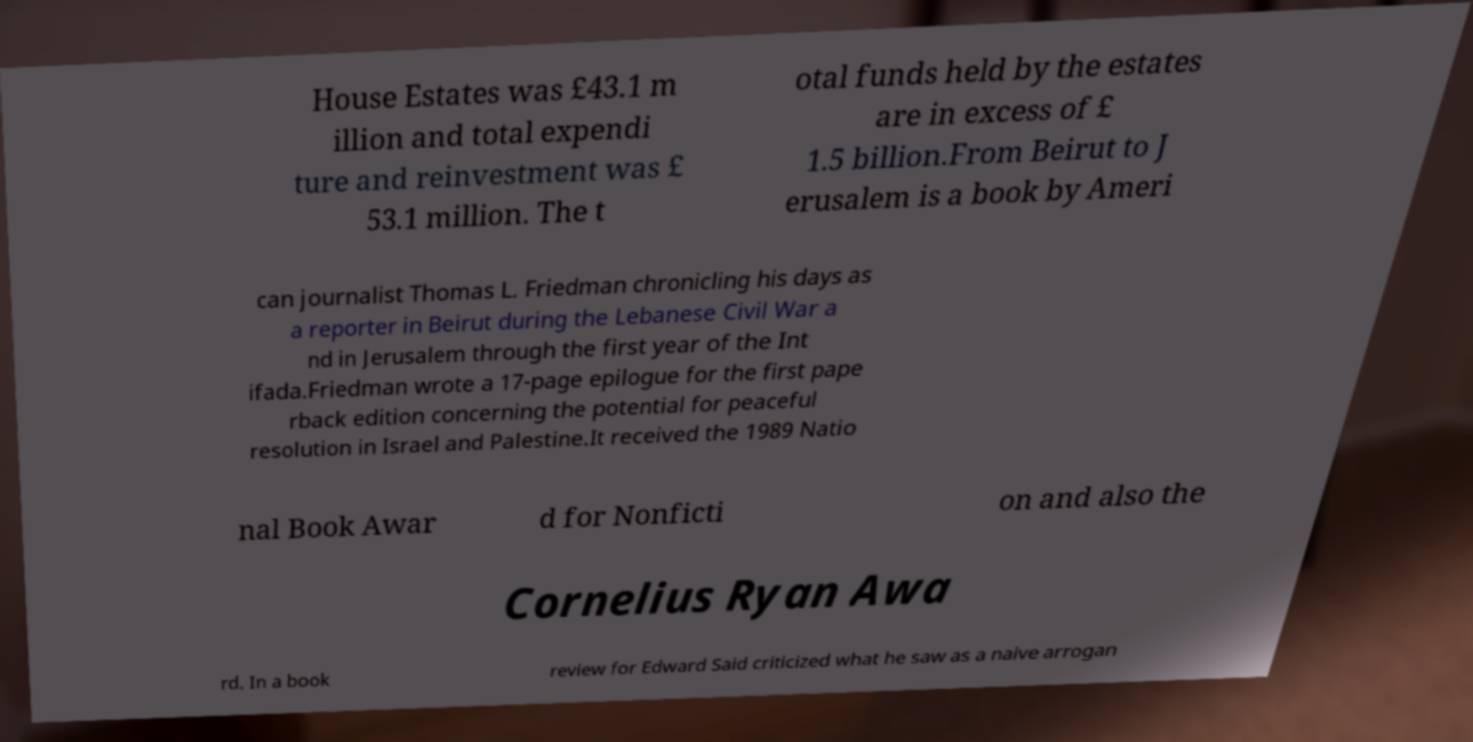What messages or text are displayed in this image? I need them in a readable, typed format. House Estates was £43.1 m illion and total expendi ture and reinvestment was £ 53.1 million. The t otal funds held by the estates are in excess of £ 1.5 billion.From Beirut to J erusalem is a book by Ameri can journalist Thomas L. Friedman chronicling his days as a reporter in Beirut during the Lebanese Civil War a nd in Jerusalem through the first year of the Int ifada.Friedman wrote a 17-page epilogue for the first pape rback edition concerning the potential for peaceful resolution in Israel and Palestine.It received the 1989 Natio nal Book Awar d for Nonficti on and also the Cornelius Ryan Awa rd. In a book review for Edward Said criticized what he saw as a naive arrogan 